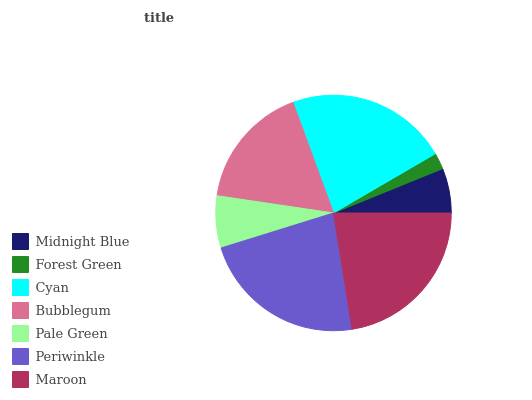Is Forest Green the minimum?
Answer yes or no. Yes. Is Periwinkle the maximum?
Answer yes or no. Yes. Is Cyan the minimum?
Answer yes or no. No. Is Cyan the maximum?
Answer yes or no. No. Is Cyan greater than Forest Green?
Answer yes or no. Yes. Is Forest Green less than Cyan?
Answer yes or no. Yes. Is Forest Green greater than Cyan?
Answer yes or no. No. Is Cyan less than Forest Green?
Answer yes or no. No. Is Bubblegum the high median?
Answer yes or no. Yes. Is Bubblegum the low median?
Answer yes or no. Yes. Is Periwinkle the high median?
Answer yes or no. No. Is Maroon the low median?
Answer yes or no. No. 